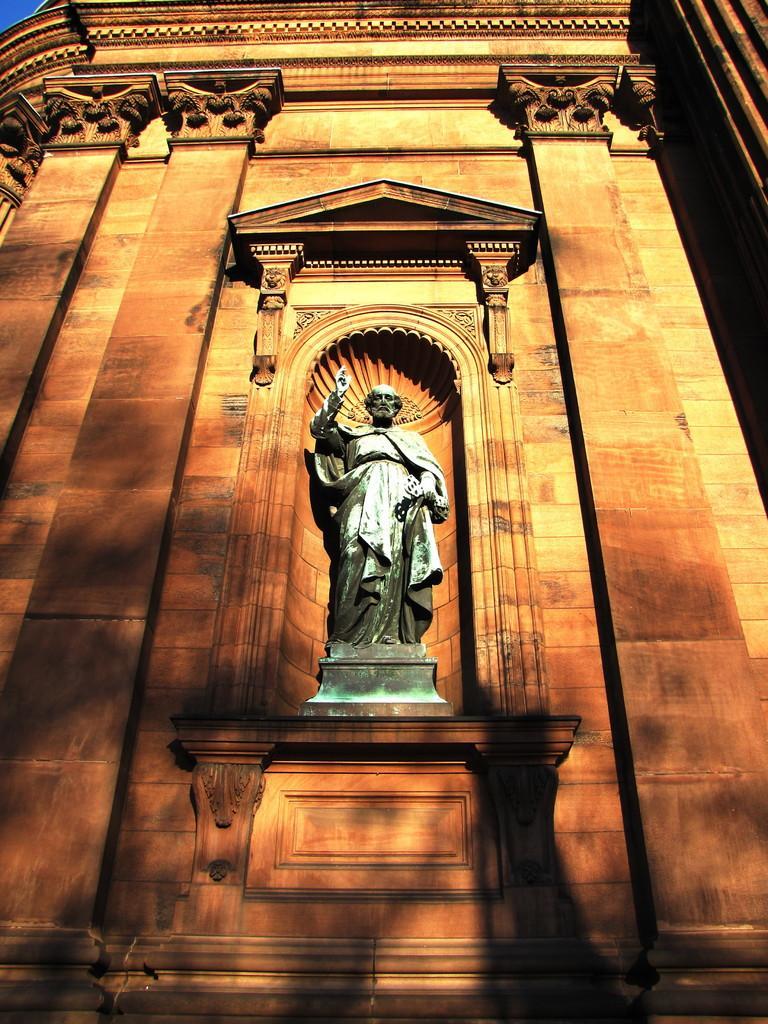In one or two sentences, can you explain what this image depicts? In this image there is a statue and there is a building. 